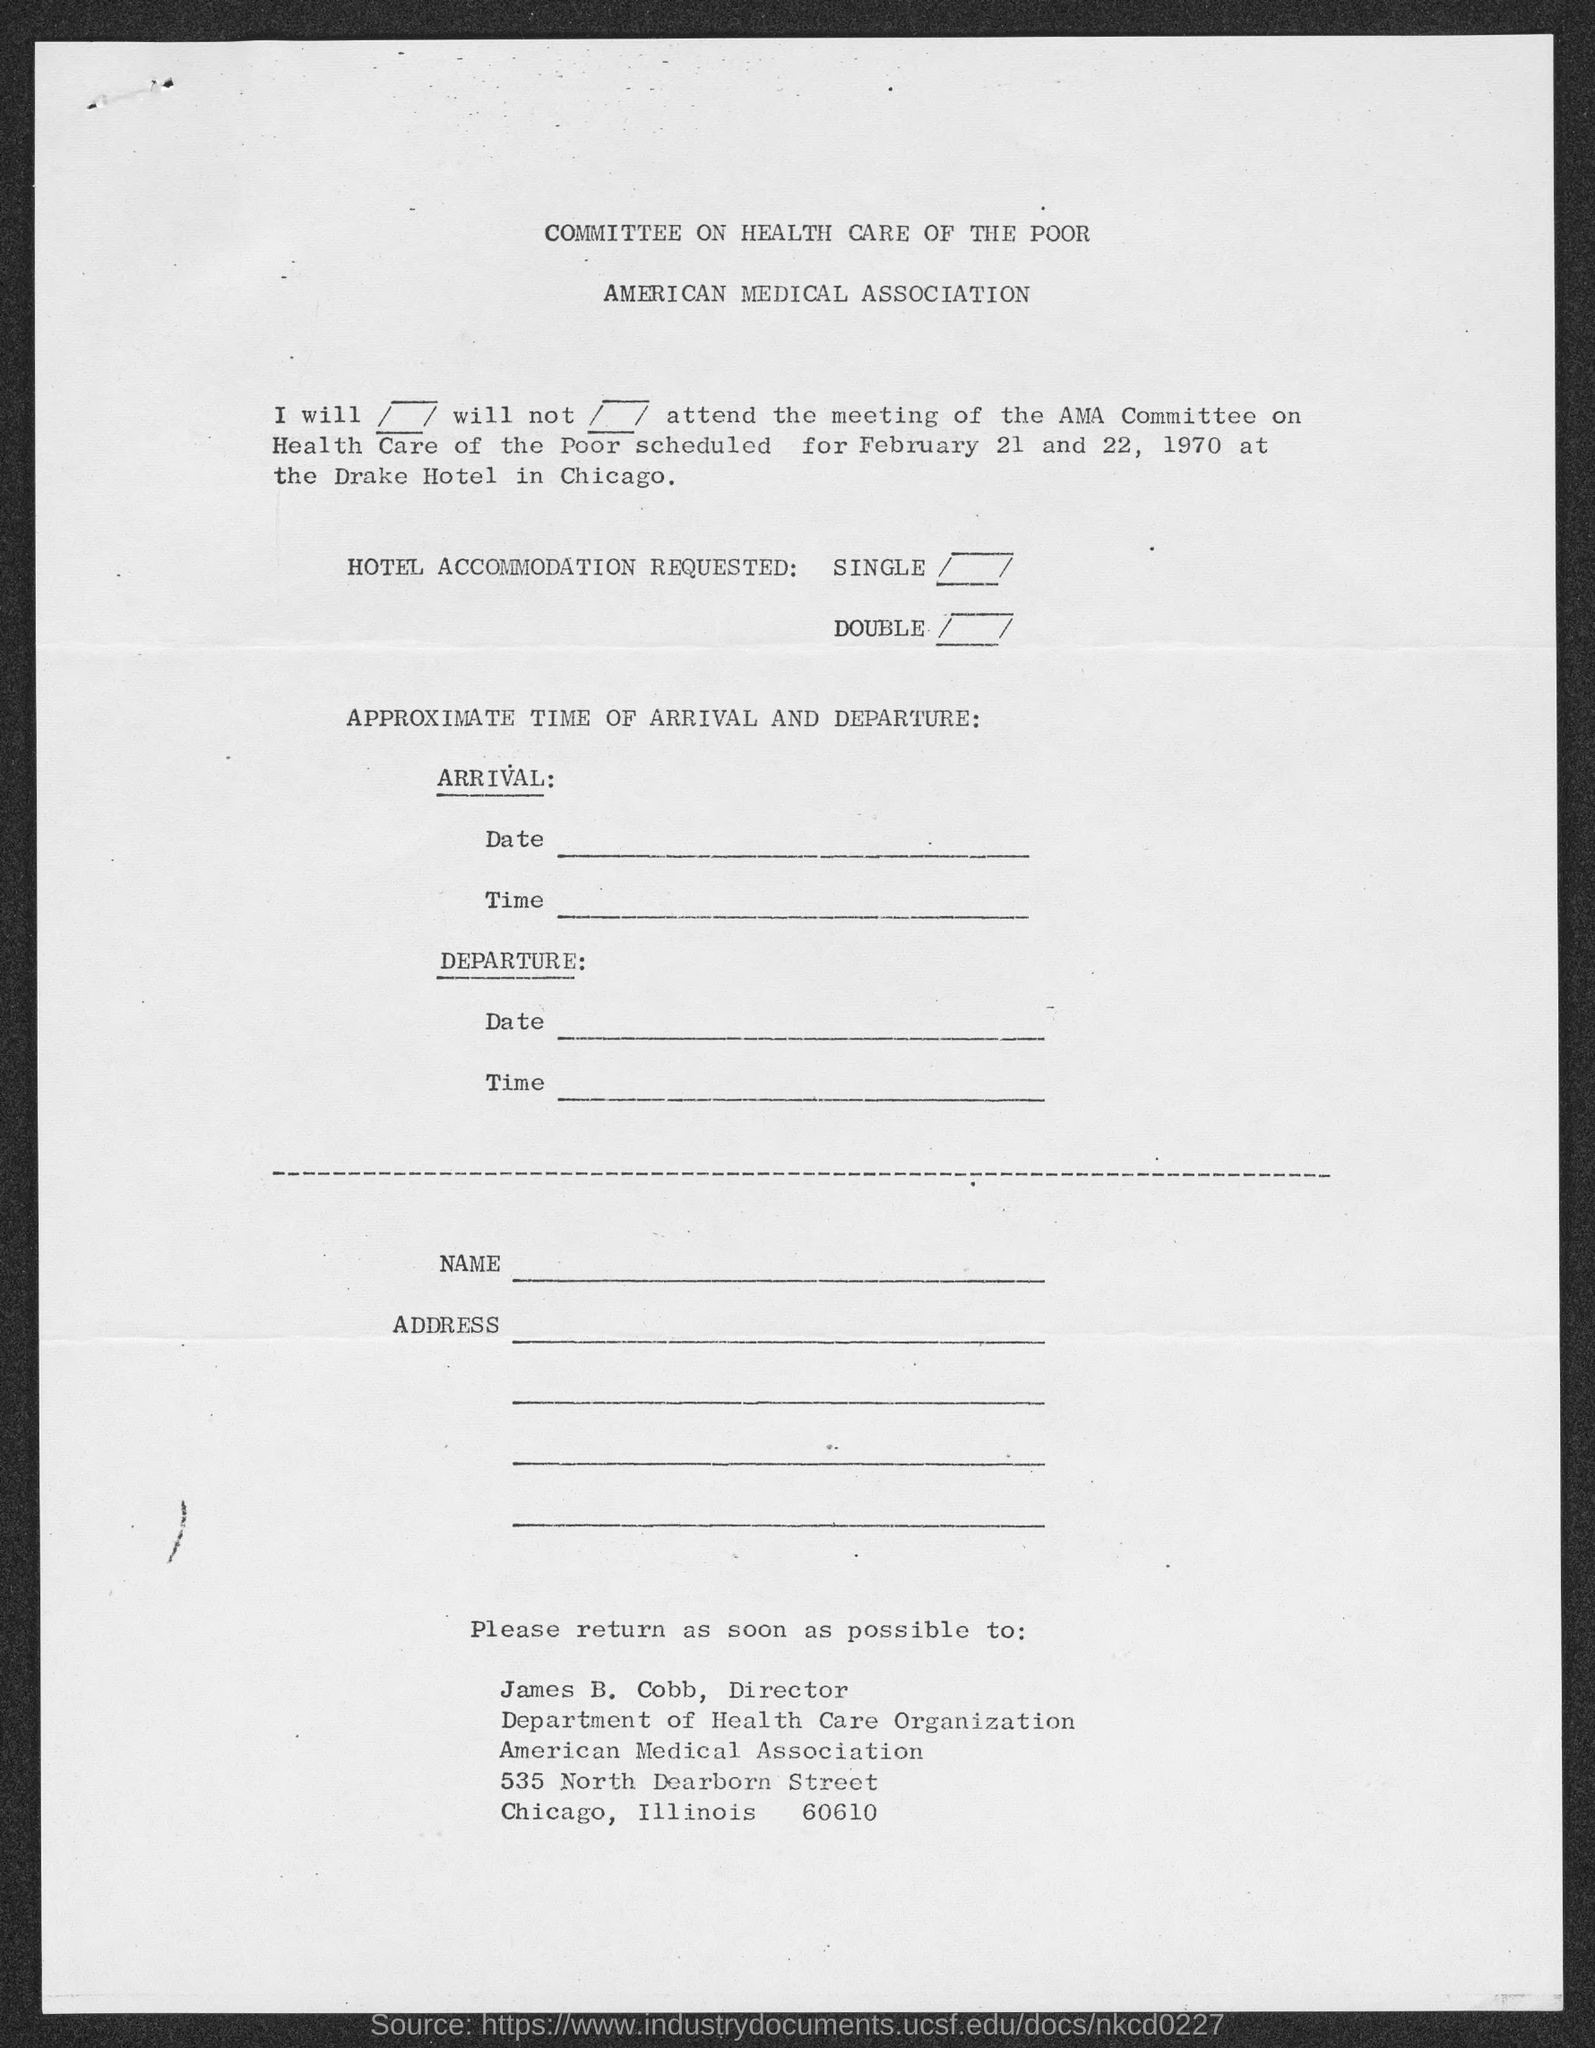In which city is american medical association at ?
Ensure brevity in your answer.  Chicago. To whom must this be returned to ?
Provide a short and direct response. James B. Cobb. What is the position of james b. cobb?
Give a very brief answer. Director. 